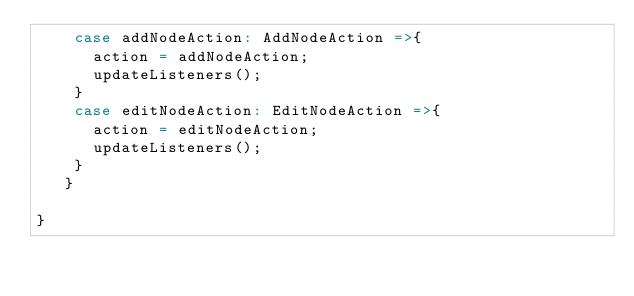Convert code to text. <code><loc_0><loc_0><loc_500><loc_500><_Scala_>    case addNodeAction: AddNodeAction =>{         
      action = addNodeAction;
      updateListeners();
    }
    case editNodeAction: EditNodeAction =>{
      action = editNodeAction;
      updateListeners();
    }
   }

}</code> 